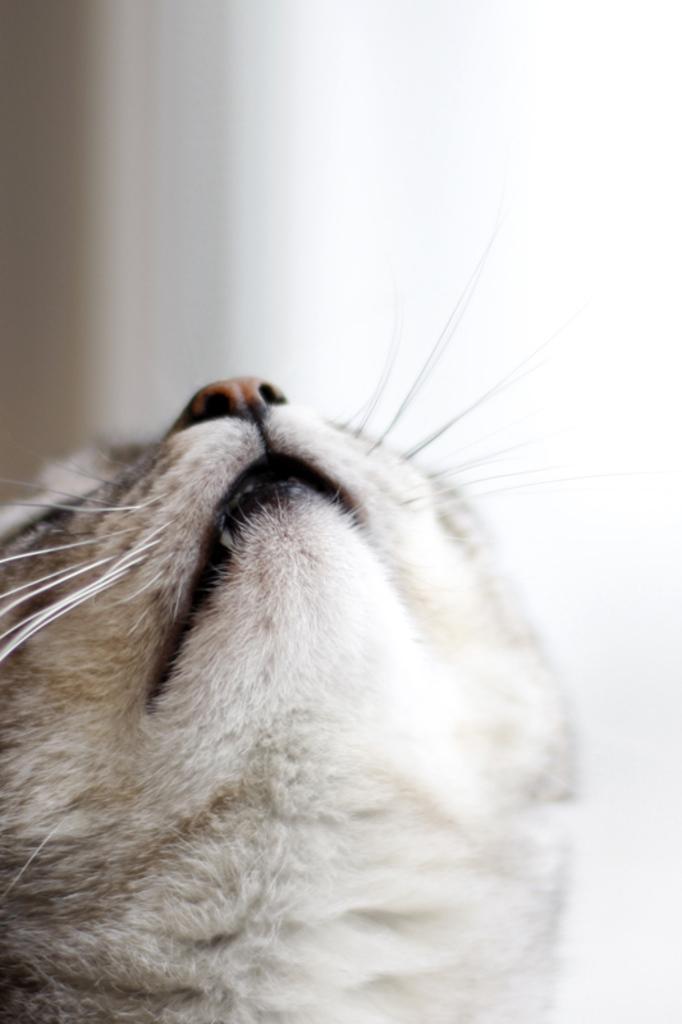In one or two sentences, can you explain what this image depicts? In this image, we can see the head of a cat. 